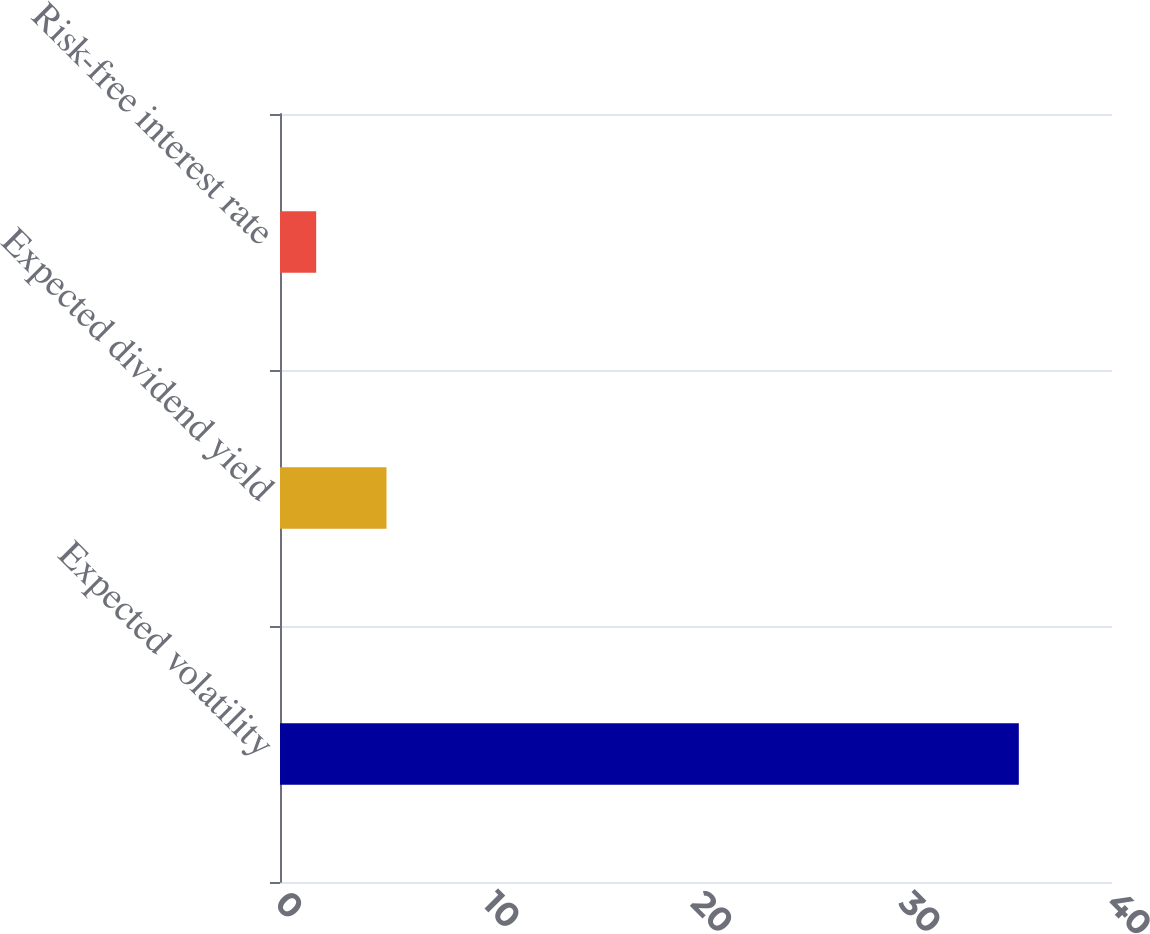Convert chart. <chart><loc_0><loc_0><loc_500><loc_500><bar_chart><fcel>Expected volatility<fcel>Expected dividend yield<fcel>Risk-free interest rate<nl><fcel>35.52<fcel>5.12<fcel>1.74<nl></chart> 